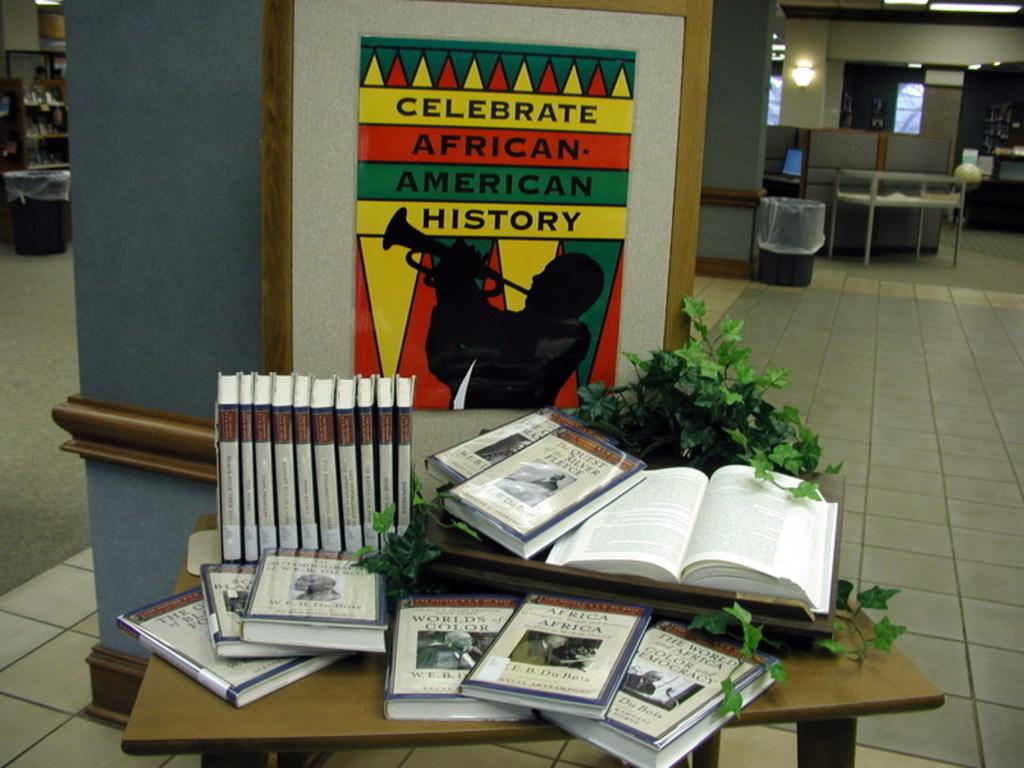<image>
Present a compact description of the photo's key features. A sign that has a person playing an instrument has the message Celebrate African American history. 